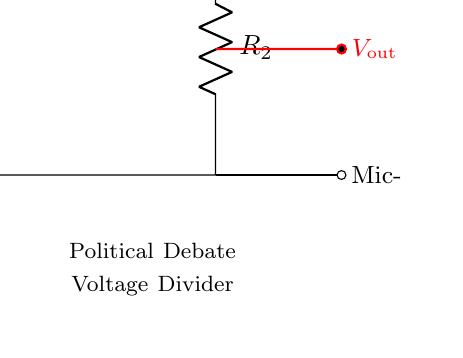What is the primary function of this circuit? This circuit is a voltage divider, designed to adjust the level of the microphone input for optimal performance during political debates.
Answer: Voltage divider What does R1 represent in the circuit? R1 is the resistor connected in series with the input voltage, used to help set the output voltage based on the voltage divider principle.
Answer: Resistor What is the output voltage denoted as in the diagram? The output voltage of the circuit is labeled as V out and is positioned between the two resistors, which indicates the adjusted signal level.
Answer: V out How many resistors are present in this circuit? The diagram clearly shows two resistors, R1 and R2, which are integral to forming the voltage divider.
Answer: Two What relationship does R1 and R2 have on V out? The values of R1 and R2 determine the ratio of the voltage output (V out) as per the voltage divider formula, showing how they work together to adjust the voltage level.
Answer: Voltage ratio What type of circuit is depicted? The circuit illustrated is an analog circuit specifically used for analog signal processing, utilizing resistors for voltage adjustment.
Answer: Analog circuit What is the significance of the battery in this setup? The battery provides the input voltage (V in), which is essential for the operation of the voltage divider, allowing for the adjustment of the microphone levels.
Answer: Power source 